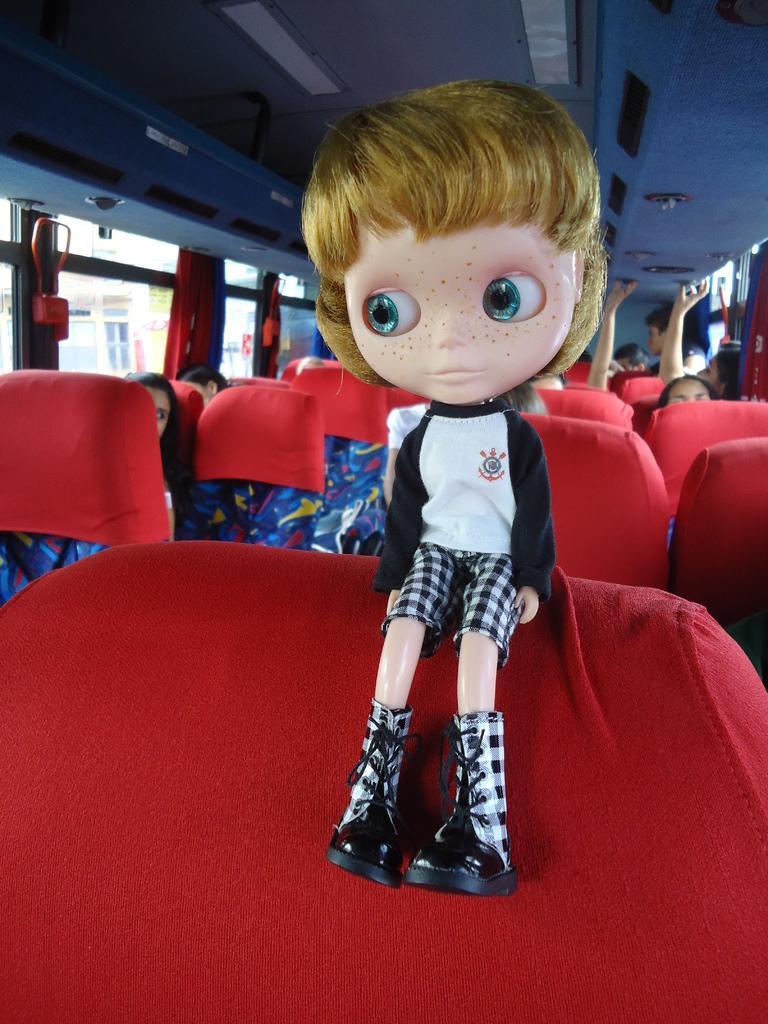Could you give a brief overview of what you see in this image? In this image we can see an inside of a vehicle. In the vehicle we can see persons sitting on the seats. In the foreground we can see a toy on a seat. At the top we can see the roof and lights. Through the glass of the vehicle we can see the buildings. 